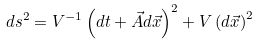<formula> <loc_0><loc_0><loc_500><loc_500>d s ^ { 2 } = V ^ { - 1 } \left ( d t + \vec { A } d \vec { x } \right ) ^ { 2 } + V \left ( d \vec { x } \right ) ^ { 2 }</formula> 